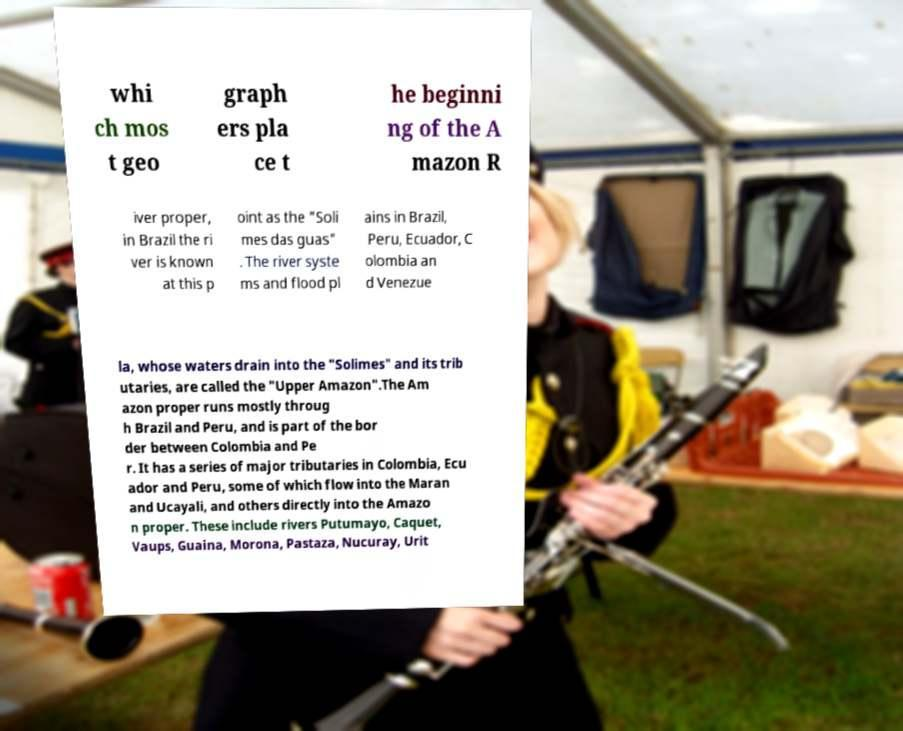Can you accurately transcribe the text from the provided image for me? whi ch mos t geo graph ers pla ce t he beginni ng of the A mazon R iver proper, in Brazil the ri ver is known at this p oint as the "Soli mes das guas" . The river syste ms and flood pl ains in Brazil, Peru, Ecuador, C olombia an d Venezue la, whose waters drain into the "Solimes" and its trib utaries, are called the "Upper Amazon".The Am azon proper runs mostly throug h Brazil and Peru, and is part of the bor der between Colombia and Pe r. It has a series of major tributaries in Colombia, Ecu ador and Peru, some of which flow into the Maran and Ucayali, and others directly into the Amazo n proper. These include rivers Putumayo, Caquet, Vaups, Guaina, Morona, Pastaza, Nucuray, Urit 